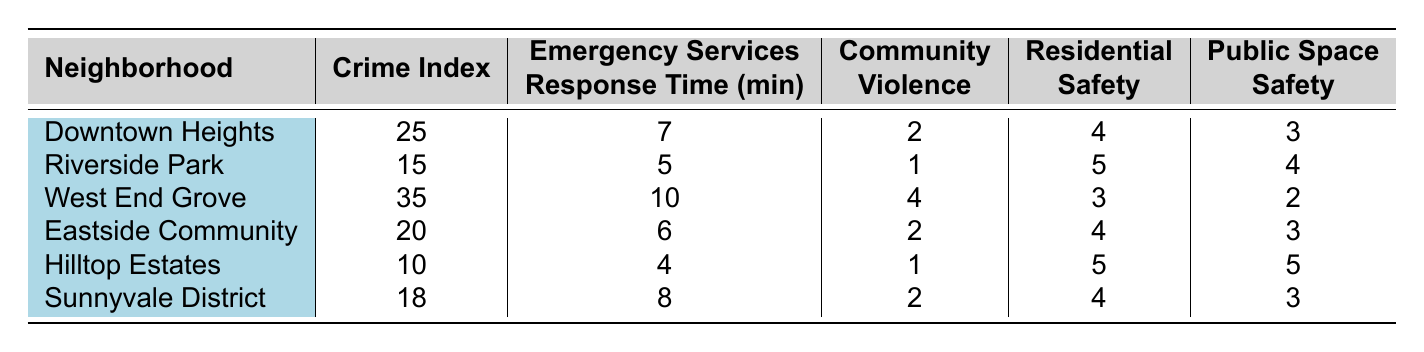What is the highest crime index among the neighborhoods? The highest crime index can be found by comparing the crime indices listed for each neighborhood. The values are 25, 15, 35, 20, 10, and 18. The highest value is 35 for West End Grove.
Answer: 35 Which neighborhood has the quickest emergency services response time? To find the quickest response time, we look for the lowest value in the emergency services response time column. The times are 7, 5, 10, 6, 4, and 8. The lowest is 4 minutes for Hilltop Estates.
Answer: Hilltop Estates Is Riverside Park the safest neighborhood in terms of residential safety? Residential safety ratings must be compared: 4 (Downtown Heights), 5 (Riverside Park), 3 (West End Grove), 4 (Eastside Community), 5 (Hilltop Estates), and 4 (Sunnyvale District). Riverside Park has a 5, which is the highest rating.
Answer: Yes What is the average community violence score for all neighborhoods? To find the average, sum the community violence scores: 2 + 1 + 4 + 2 + 1 + 2 = 12. There are 6 neighborhoods, so the average is 12/6 = 2.
Answer: 2 Which neighborhood has the lowest public space safety score? We need to identify the lowest score in the public space safety column: 3 (Downtown Heights), 4 (Riverside Park), 2 (West End Grove), 3 (Eastside Community), 5 (Hilltop Estates), and 3 (Sunnyvale District). The lowest is 2 for West End Grove.
Answer: West End Grove What is the difference between the highest and lowest crime indices? The highest crime index is 35 (West End Grove) and the lowest is 10 (Hilltop Estates). The difference is calculated as 35 - 10 = 25.
Answer: 25 Which neighborhood has the highest score in both residential safety and public space safety? We must compare the residential safety and public space safety scores for all neighborhoods. Hilltop Estates scores 5 in both categories, which is the highest for both.
Answer: Hilltop Estates Which neighborhood presents the most community violence? The community violence scores are 2, 1, 4, 2, 1, and 2. The highest score is 4 for West End Grove.
Answer: West End Grove What is the total emergency services response time for all neighborhoods? We add the response times: 7 + 5 + 10 + 6 + 4 + 8 = 40 minutes.
Answer: 40 minutes Is there a neighborhood where residential safety is equal or greater than 5? By reviewing the residential safety scores, Hilltop Estates (5) and Riverside Park (5) meet this condition.
Answer: Yes 